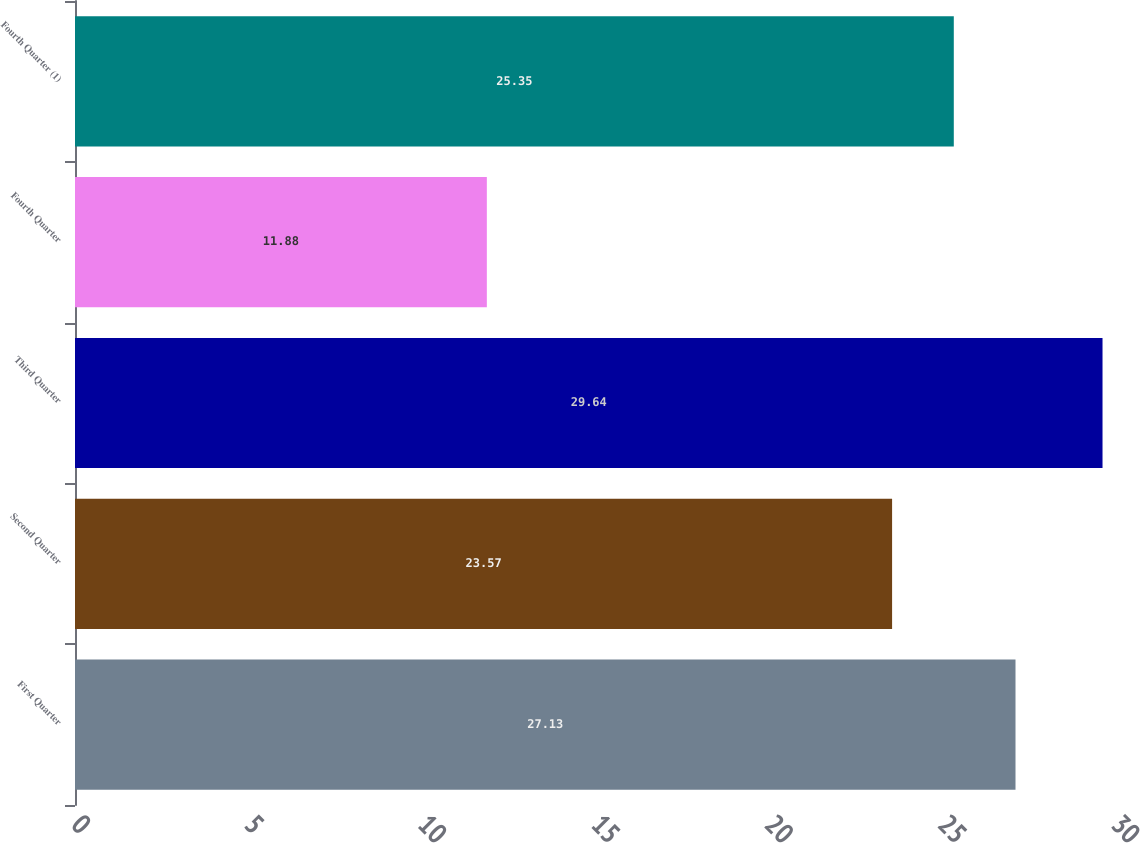Convert chart. <chart><loc_0><loc_0><loc_500><loc_500><bar_chart><fcel>First Quarter<fcel>Second Quarter<fcel>Third Quarter<fcel>Fourth Quarter<fcel>Fourth Quarter (1)<nl><fcel>27.13<fcel>23.57<fcel>29.64<fcel>11.88<fcel>25.35<nl></chart> 